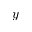<formula> <loc_0><loc_0><loc_500><loc_500>y</formula> 